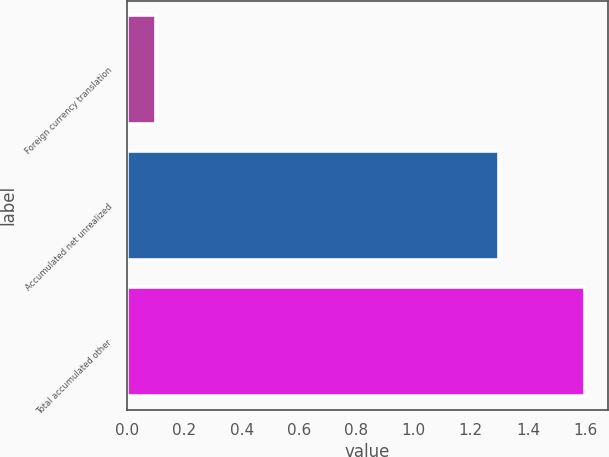<chart> <loc_0><loc_0><loc_500><loc_500><bar_chart><fcel>Foreign currency translation<fcel>Accumulated net unrealized<fcel>Total accumulated other<nl><fcel>0.1<fcel>1.3<fcel>1.6<nl></chart> 